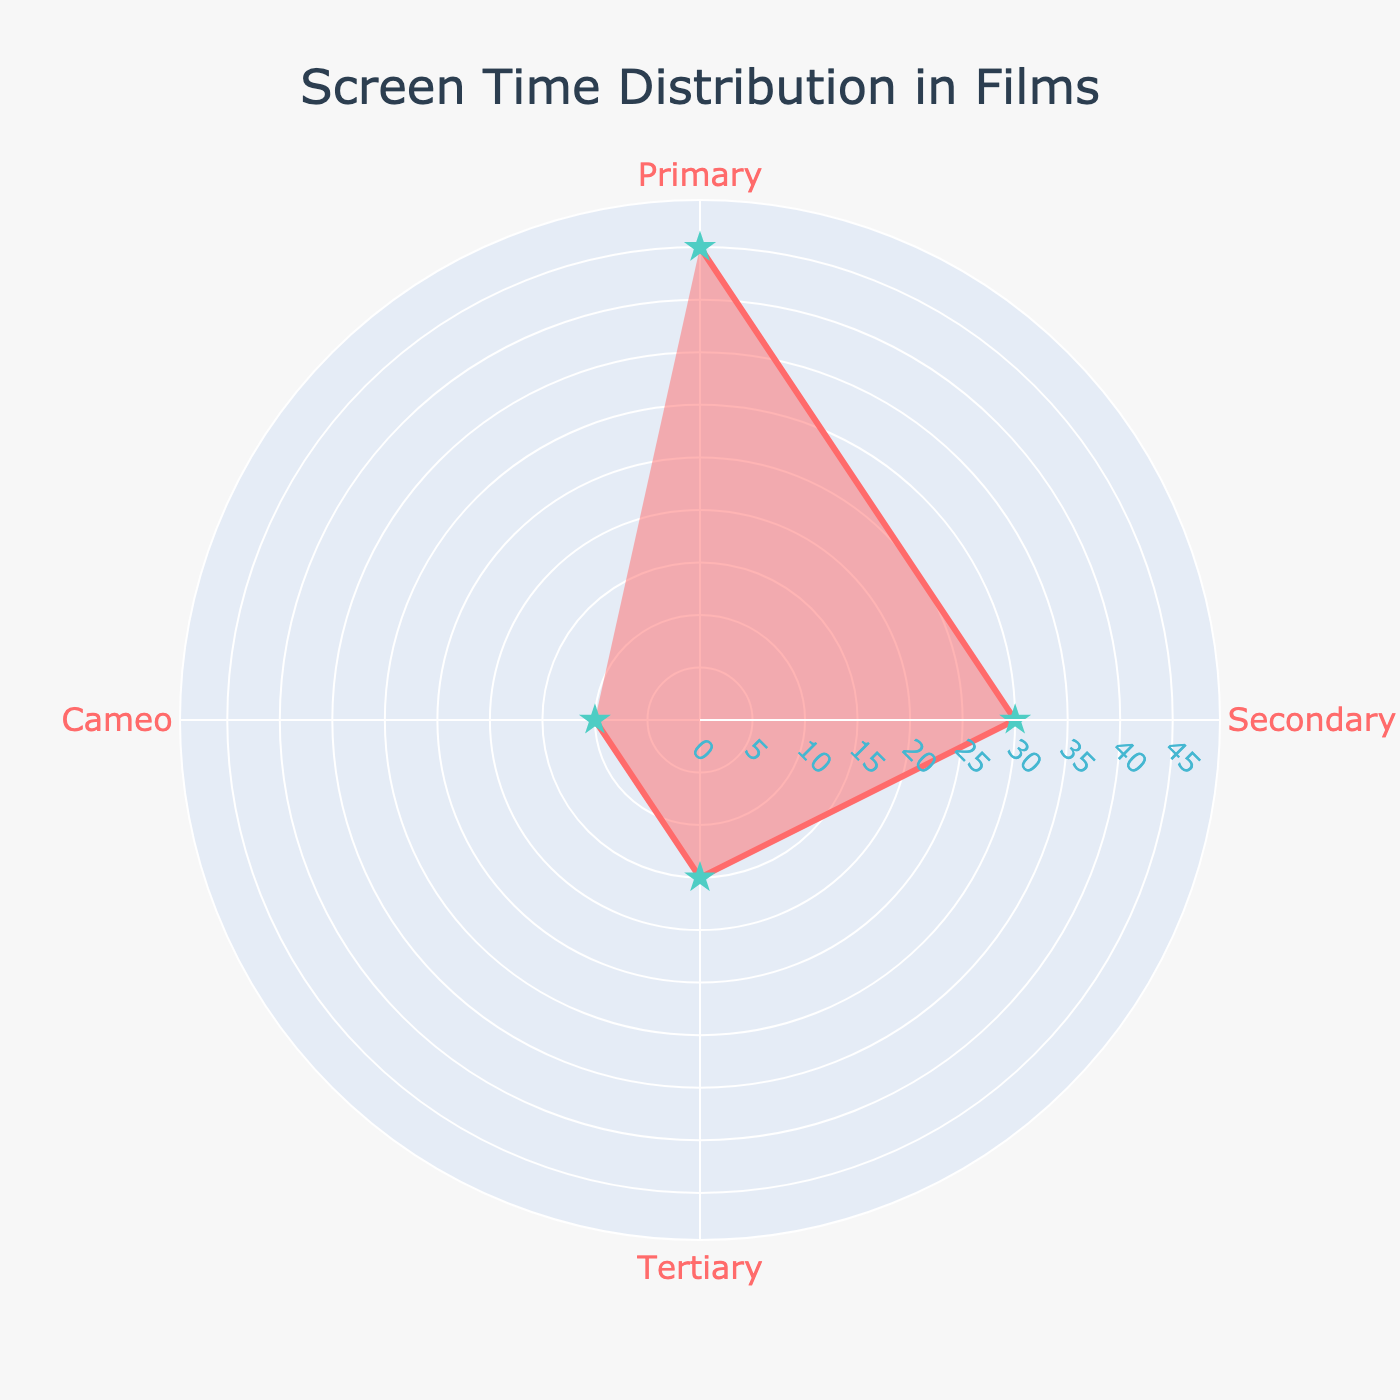What's the title of the figure? The title of the figure is displayed at the top center of the figure in larger font.
Answer: Screen Time Distribution in Films How many character categories are displayed in the figure? There are four distinct categories marked on the angular axis of the polar chart.
Answer: Four Which character type has the highest screen time percentage? By observing the radial values for each character type, the 'Primary' character shows the highest percentage.
Answer: Primary What's the total percentage of screen time covered by Secondary and Tertiary characters? The percentage for Secondary characters is 30, and Tertiary is 15. Adding these together gives 30 + 15 = 45.
Answer: 45 Which character has the smallest screen time percentage, and what is it? The smallest percentage value on the radial axis belongs to the 'Cameo' character.
Answer: Cameo, 10 How much more screen time do Primary characters have compared to Tertiary characters? The screen time for Primary characters is 45, and for Tertiary characters, it is 15. The difference is 45 - 15.
Answer: 30 What is the average screen time percentage of all character types? Adding all screen time values: 45 (Primary) + 30 (Secondary) + 15 (Tertiary) + 10 (Cameo) = 100, then divide by the number of categories, which is 4. 100 / 4 = 25
Answer: 25 Which character type's screen time is equal to or greater than 30? By looking at the values on the radial axis, 'Primary' and 'Secondary' characters have screen times of 45 and 30, respectively.
Answer: Primary and Secondary What is the combined screen time percentage of the characters with less than 20% screen time each? Tertiary and Cameo characters have less than 20% screen time. Their combined percentages are: 15 + 10 = 25.
Answer: 25 How is the radial axis indicated in the figure? The radial axis displays percentage values and is configured to be visible, ranging from 0 to slightly above the maximum screen time percentage.
Answer: Percentage values 